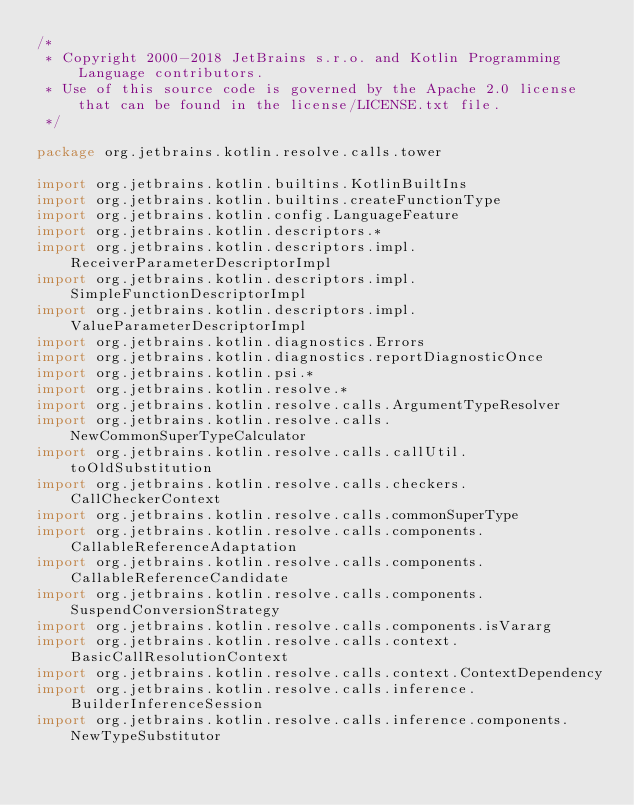<code> <loc_0><loc_0><loc_500><loc_500><_Kotlin_>/*
 * Copyright 2000-2018 JetBrains s.r.o. and Kotlin Programming Language contributors.
 * Use of this source code is governed by the Apache 2.0 license that can be found in the license/LICENSE.txt file.
 */

package org.jetbrains.kotlin.resolve.calls.tower

import org.jetbrains.kotlin.builtins.KotlinBuiltIns
import org.jetbrains.kotlin.builtins.createFunctionType
import org.jetbrains.kotlin.config.LanguageFeature
import org.jetbrains.kotlin.descriptors.*
import org.jetbrains.kotlin.descriptors.impl.ReceiverParameterDescriptorImpl
import org.jetbrains.kotlin.descriptors.impl.SimpleFunctionDescriptorImpl
import org.jetbrains.kotlin.descriptors.impl.ValueParameterDescriptorImpl
import org.jetbrains.kotlin.diagnostics.Errors
import org.jetbrains.kotlin.diagnostics.reportDiagnosticOnce
import org.jetbrains.kotlin.psi.*
import org.jetbrains.kotlin.resolve.*
import org.jetbrains.kotlin.resolve.calls.ArgumentTypeResolver
import org.jetbrains.kotlin.resolve.calls.NewCommonSuperTypeCalculator
import org.jetbrains.kotlin.resolve.calls.callUtil.toOldSubstitution
import org.jetbrains.kotlin.resolve.calls.checkers.CallCheckerContext
import org.jetbrains.kotlin.resolve.calls.commonSuperType
import org.jetbrains.kotlin.resolve.calls.components.CallableReferenceAdaptation
import org.jetbrains.kotlin.resolve.calls.components.CallableReferenceCandidate
import org.jetbrains.kotlin.resolve.calls.components.SuspendConversionStrategy
import org.jetbrains.kotlin.resolve.calls.components.isVararg
import org.jetbrains.kotlin.resolve.calls.context.BasicCallResolutionContext
import org.jetbrains.kotlin.resolve.calls.context.ContextDependency
import org.jetbrains.kotlin.resolve.calls.inference.BuilderInferenceSession
import org.jetbrains.kotlin.resolve.calls.inference.components.NewTypeSubstitutor</code> 